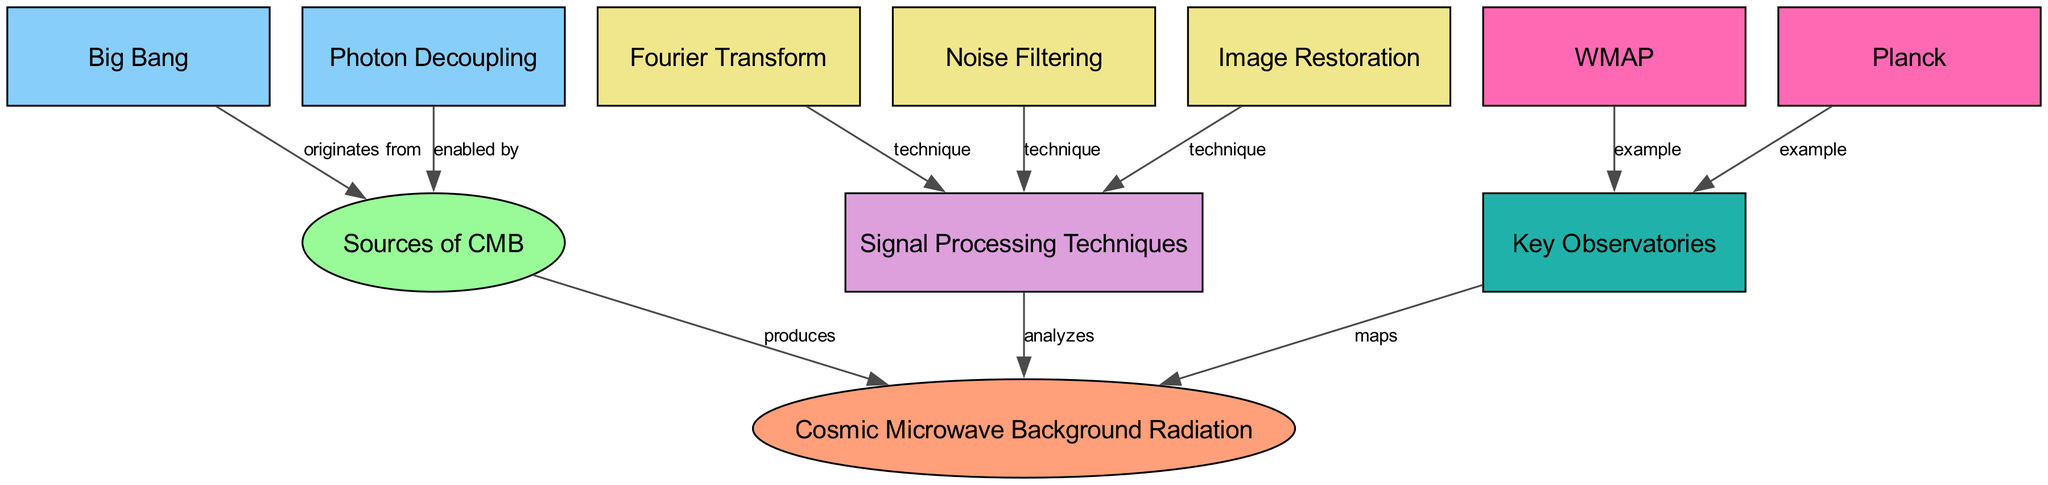What does CMB stand for? The acronym CMB is depicted in the diagram as representing "Cosmic Microwave Background Radiation." This is confirmed by the label in the corresponding node.
Answer: Cosmic Microwave Background Radiation How many sources are there for CMB? By counting the nodes labeled as "Sources" leading to CMB, we find two labeled nodes: "Big Bang" and "Photon Decoupling." This indicates the two sources identified in the diagram.
Answer: 2 Which observatory is an example of a key observatory in the diagram? The diagram presents two nodes under "Key Observatories": WMAP and Planck. Either of these can be identified as an example based on the provided diagram.
Answer: WMAP What technique is used for signal processing in the analysis of CMB? The diagram includes multiple techniques related to signal processing; however, "Fourier Transform" is explicitly mentioned as one of the techniques, which is crucial for analyzing CMB.
Answer: Fourier Transform Which event does the source "Big Bang" originate from? The diagram states that "Big Bang" originates from the "Sources" node, indicating that it is a foundational source of CMB in the context of the diagram.
Answer: Sources How does "Photon Decoupling" relate to CMB? The edge labeled "enabled by" links "Photon Decoupling" to the "Sources" node, suggesting that it plays a role in the generation or characteristics of CMB.
Answer: enabled by What are the two key observatories mentioned in the diagram? The nodes under "Key Observatories" denote two names: "WMAP" and "Planck," thereby identifying the key observatories related to CMB mapping according to the diagram.
Answer: WMAP and Planck Which signal processing technique relates to enhancing images in the analysis of CMB? The diagram lists "Image Restoration" under signal processing techniques, indicating that it specifically pertains to enhancing and improving the quality of images obtained during CMB analysis.
Answer: Image Restoration How do the techniques of "Noise Filtering" and "Image Restoration" contribute to the analysis of CMB? Both "Noise Filtering" and "Image Restoration" are classified under the node "Signal Processing Techniques," indicating that they both facilitate the analysis of CMB by reducing noise and improving image clarity respectively.
Answer: analyzes 